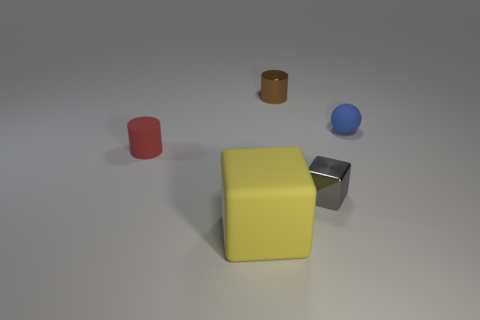Add 1 gray metallic cubes. How many objects exist? 6 Subtract all cubes. How many objects are left? 3 Subtract 0 purple blocks. How many objects are left? 5 Subtract all big yellow cylinders. Subtract all small gray blocks. How many objects are left? 4 Add 5 spheres. How many spheres are left? 6 Add 1 large blue shiny balls. How many large blue shiny balls exist? 1 